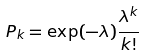Convert formula to latex. <formula><loc_0><loc_0><loc_500><loc_500>P _ { k } = \exp ( - \lambda ) \frac { \lambda ^ { k } } { k ! }</formula> 